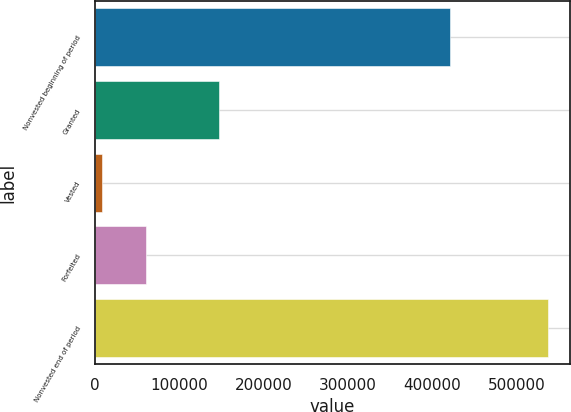Convert chart. <chart><loc_0><loc_0><loc_500><loc_500><bar_chart><fcel>Nonvested beginning of period<fcel>Granted<fcel>Vested<fcel>Forfeited<fcel>Nonvested end of period<nl><fcel>421500<fcel>147200<fcel>8000<fcel>60870<fcel>536700<nl></chart> 